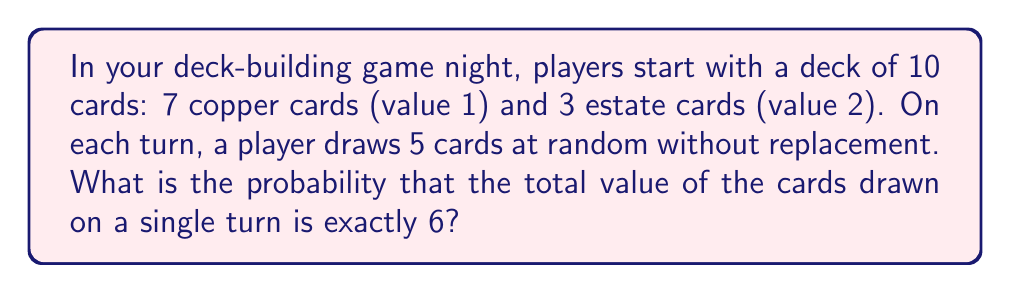Show me your answer to this math problem. Let's approach this step-by-step:

1) First, we need to identify the possible combinations of cards that sum to 6:
   - 4 copper cards (1 each) and 1 estate card (2)
   - 2 copper cards (1 each) and 2 estate cards (2 each)

2) Now, let's calculate the probability of each combination:

   a) For 4 copper and 1 estate:
      $P(4C, 1E) = \frac{\binom{7}{4} \cdot \binom{3}{1}}{\binom{10}{5}}$
      
      Where $\binom{7}{4}$ is the number of ways to choose 4 copper cards from 7,
      $\binom{3}{1}$ is the number of ways to choose 1 estate card from 3,
      and $\binom{10}{5}$ is the total number of ways to draw 5 cards from 10.

      $P(4C, 1E) = \frac{35 \cdot 3}{252} = \frac{105}{252}$

   b) For 2 copper and 2 estate:
      $P(2C, 2E) = \frac{\binom{7}{2} \cdot \binom{3}{2}}{\binom{10}{5}}$

      $P(2C, 2E) = \frac{21 \cdot 3}{252} = \frac{63}{252}$

3) The total probability is the sum of these two probabilities:

   $P(\text{total} = 6) = P(4C, 1E) + P(2C, 2E)$
   
   $= \frac{105}{252} + \frac{63}{252} = \frac{168}{252} = \frac{2}{3}$
Answer: The probability that the total value of the cards drawn on a single turn is exactly 6 is $\frac{2}{3}$ or approximately 0.6667. 